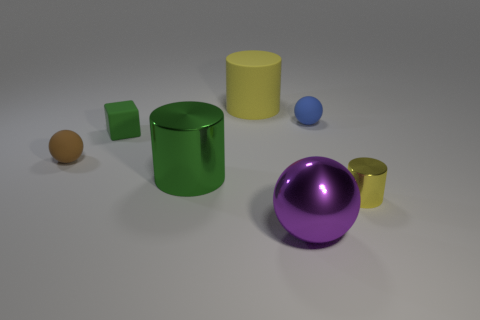Subtract all green metallic cylinders. How many cylinders are left? 2 Subtract all yellow cylinders. How many blue balls are left? 1 Subtract all brown matte spheres. Subtract all large matte objects. How many objects are left? 5 Add 6 tiny yellow cylinders. How many tiny yellow cylinders are left? 7 Add 7 cyan balls. How many cyan balls exist? 7 Add 2 gray things. How many objects exist? 9 Subtract all green cylinders. How many cylinders are left? 2 Subtract 0 purple cylinders. How many objects are left? 7 Subtract all cylinders. How many objects are left? 4 Subtract 1 balls. How many balls are left? 2 